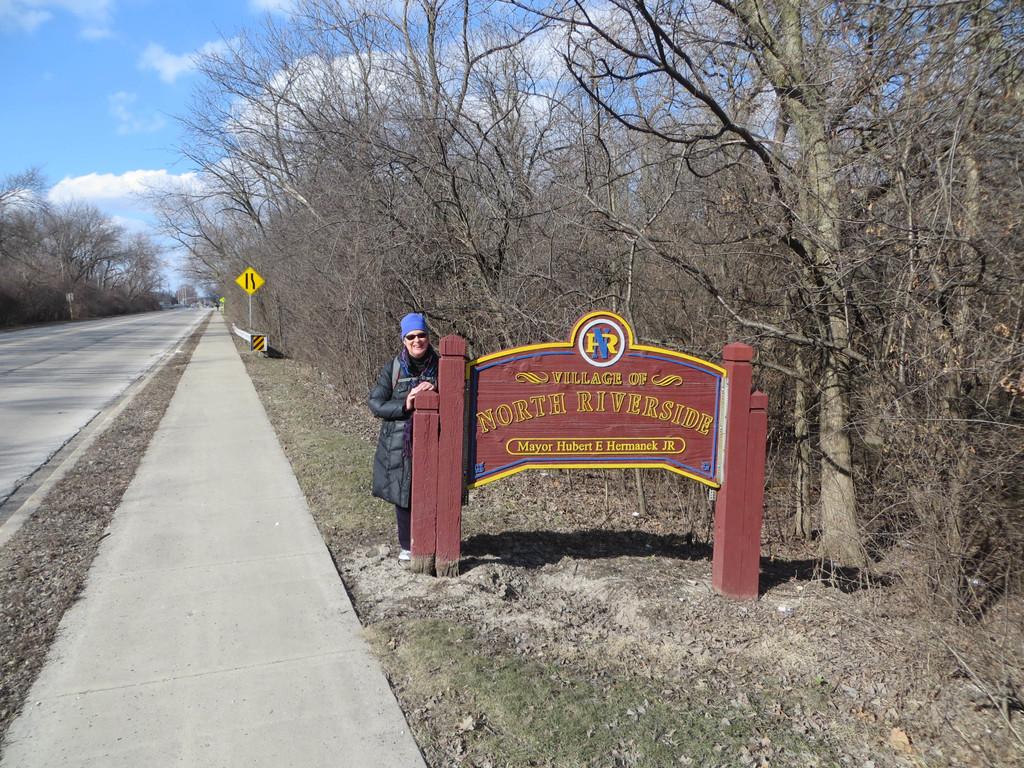What is the name of the village?
Provide a succinct answer. North riverside. Who is the mayor of the town?
Your response must be concise. Hubert e hermanek jr. 